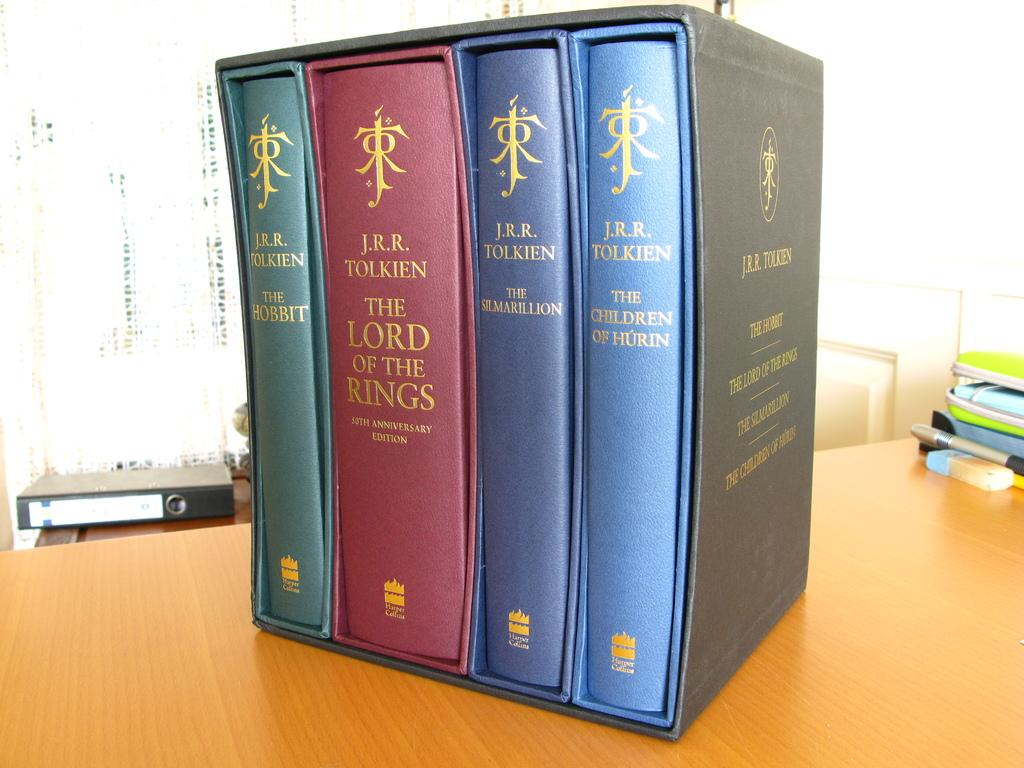Provide a one-sentence caption for the provided image. Group of books that appear to be lord of the rings. 